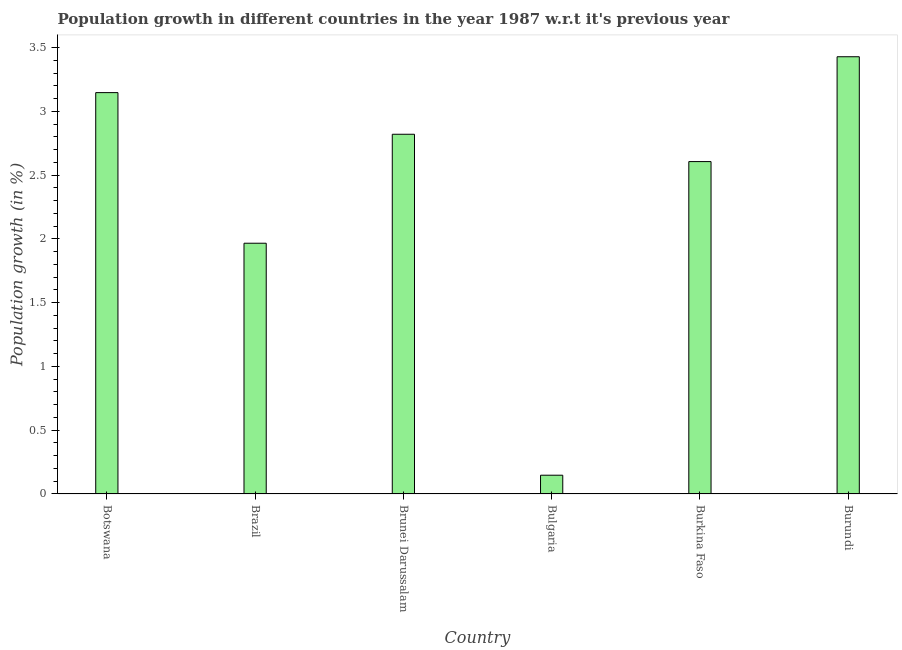Does the graph contain any zero values?
Ensure brevity in your answer.  No. Does the graph contain grids?
Offer a very short reply. No. What is the title of the graph?
Your answer should be very brief. Population growth in different countries in the year 1987 w.r.t it's previous year. What is the label or title of the Y-axis?
Make the answer very short. Population growth (in %). What is the population growth in Botswana?
Your answer should be compact. 3.15. Across all countries, what is the maximum population growth?
Your answer should be compact. 3.43. Across all countries, what is the minimum population growth?
Ensure brevity in your answer.  0.15. In which country was the population growth maximum?
Your answer should be compact. Burundi. What is the sum of the population growth?
Your answer should be very brief. 14.11. What is the difference between the population growth in Botswana and Bulgaria?
Give a very brief answer. 3. What is the average population growth per country?
Your answer should be very brief. 2.35. What is the median population growth?
Your response must be concise. 2.71. In how many countries, is the population growth greater than 2.3 %?
Keep it short and to the point. 4. What is the ratio of the population growth in Brunei Darussalam to that in Burkina Faso?
Your answer should be compact. 1.08. What is the difference between the highest and the second highest population growth?
Give a very brief answer. 0.28. Is the sum of the population growth in Brunei Darussalam and Burkina Faso greater than the maximum population growth across all countries?
Offer a very short reply. Yes. What is the difference between the highest and the lowest population growth?
Your response must be concise. 3.28. How many bars are there?
Ensure brevity in your answer.  6. Are all the bars in the graph horizontal?
Make the answer very short. No. How many countries are there in the graph?
Make the answer very short. 6. Are the values on the major ticks of Y-axis written in scientific E-notation?
Ensure brevity in your answer.  No. What is the Population growth (in %) in Botswana?
Offer a very short reply. 3.15. What is the Population growth (in %) of Brazil?
Keep it short and to the point. 1.97. What is the Population growth (in %) in Brunei Darussalam?
Your response must be concise. 2.82. What is the Population growth (in %) of Bulgaria?
Keep it short and to the point. 0.15. What is the Population growth (in %) in Burkina Faso?
Ensure brevity in your answer.  2.61. What is the Population growth (in %) in Burundi?
Provide a succinct answer. 3.43. What is the difference between the Population growth (in %) in Botswana and Brazil?
Give a very brief answer. 1.18. What is the difference between the Population growth (in %) in Botswana and Brunei Darussalam?
Your response must be concise. 0.33. What is the difference between the Population growth (in %) in Botswana and Bulgaria?
Make the answer very short. 3. What is the difference between the Population growth (in %) in Botswana and Burkina Faso?
Ensure brevity in your answer.  0.54. What is the difference between the Population growth (in %) in Botswana and Burundi?
Give a very brief answer. -0.28. What is the difference between the Population growth (in %) in Brazil and Brunei Darussalam?
Offer a very short reply. -0.85. What is the difference between the Population growth (in %) in Brazil and Bulgaria?
Make the answer very short. 1.82. What is the difference between the Population growth (in %) in Brazil and Burkina Faso?
Make the answer very short. -0.64. What is the difference between the Population growth (in %) in Brazil and Burundi?
Ensure brevity in your answer.  -1.46. What is the difference between the Population growth (in %) in Brunei Darussalam and Bulgaria?
Keep it short and to the point. 2.67. What is the difference between the Population growth (in %) in Brunei Darussalam and Burkina Faso?
Offer a terse response. 0.21. What is the difference between the Population growth (in %) in Brunei Darussalam and Burundi?
Keep it short and to the point. -0.61. What is the difference between the Population growth (in %) in Bulgaria and Burkina Faso?
Your answer should be very brief. -2.46. What is the difference between the Population growth (in %) in Bulgaria and Burundi?
Ensure brevity in your answer.  -3.28. What is the difference between the Population growth (in %) in Burkina Faso and Burundi?
Keep it short and to the point. -0.82. What is the ratio of the Population growth (in %) in Botswana to that in Brazil?
Offer a very short reply. 1.6. What is the ratio of the Population growth (in %) in Botswana to that in Brunei Darussalam?
Make the answer very short. 1.12. What is the ratio of the Population growth (in %) in Botswana to that in Bulgaria?
Make the answer very short. 21.39. What is the ratio of the Population growth (in %) in Botswana to that in Burkina Faso?
Offer a terse response. 1.21. What is the ratio of the Population growth (in %) in Botswana to that in Burundi?
Give a very brief answer. 0.92. What is the ratio of the Population growth (in %) in Brazil to that in Brunei Darussalam?
Offer a terse response. 0.7. What is the ratio of the Population growth (in %) in Brazil to that in Bulgaria?
Provide a succinct answer. 13.36. What is the ratio of the Population growth (in %) in Brazil to that in Burkina Faso?
Provide a succinct answer. 0.75. What is the ratio of the Population growth (in %) in Brazil to that in Burundi?
Offer a terse response. 0.57. What is the ratio of the Population growth (in %) in Brunei Darussalam to that in Bulgaria?
Provide a succinct answer. 19.17. What is the ratio of the Population growth (in %) in Brunei Darussalam to that in Burkina Faso?
Give a very brief answer. 1.08. What is the ratio of the Population growth (in %) in Brunei Darussalam to that in Burundi?
Your answer should be very brief. 0.82. What is the ratio of the Population growth (in %) in Bulgaria to that in Burkina Faso?
Your answer should be very brief. 0.06. What is the ratio of the Population growth (in %) in Bulgaria to that in Burundi?
Make the answer very short. 0.04. What is the ratio of the Population growth (in %) in Burkina Faso to that in Burundi?
Offer a very short reply. 0.76. 